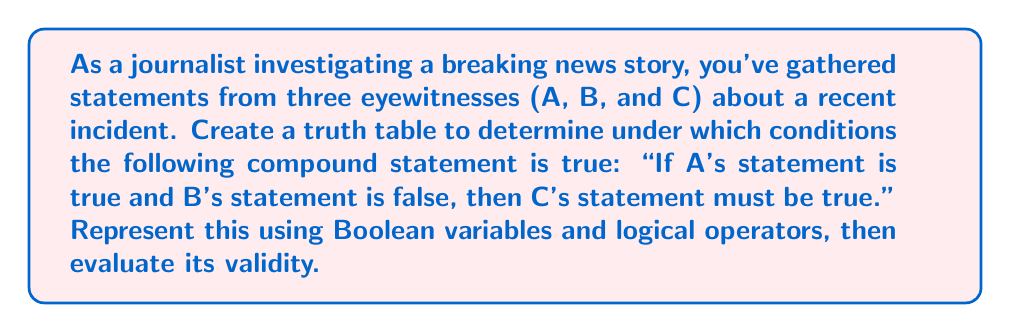Show me your answer to this math problem. Let's approach this step-by-step:

1) First, we need to assign Boolean variables to each eyewitness statement:
   A: A's statement
   B: B's statement
   C: C's statement

2) The compound statement can be represented in Boolean algebra as:
   $$(A \land \lnot B) \rightarrow C$$

3) To create a truth table, we need to consider all possible combinations of truth values for A, B, and C. There are $2^3 = 8$ possible combinations.

4) Let's create the truth table:

   $$\begin{array}{|c|c|c|c|c|c|}
   \hline
   A & B & C & A \land \lnot B & (A \land \lnot B) \rightarrow C \\
   \hline
   T & T & T & F & T \\
   T & T & F & F & T \\
   T & F & T & T & T \\
   T & F & F & T & F \\
   F & T & T & F & T \\
   F & T & F & F & T \\
   F & F & T & F & T \\
   F & F & F & F & T \\
   \hline
   \end{array}$$

5) To evaluate $(A \land \lnot B)$, we first negate B, then AND it with A.

6) For the implication $(A \land \lnot B) \rightarrow C$, it's false only when the left side is true and the right side is false. This occurs in only one case: when A is true, B is false, and C is false.

7) The compound statement is true in 7 out of 8 cases, making it valid in most scenarios but not always.
Answer: The compound statement is true in 7 out of 8 cases. 